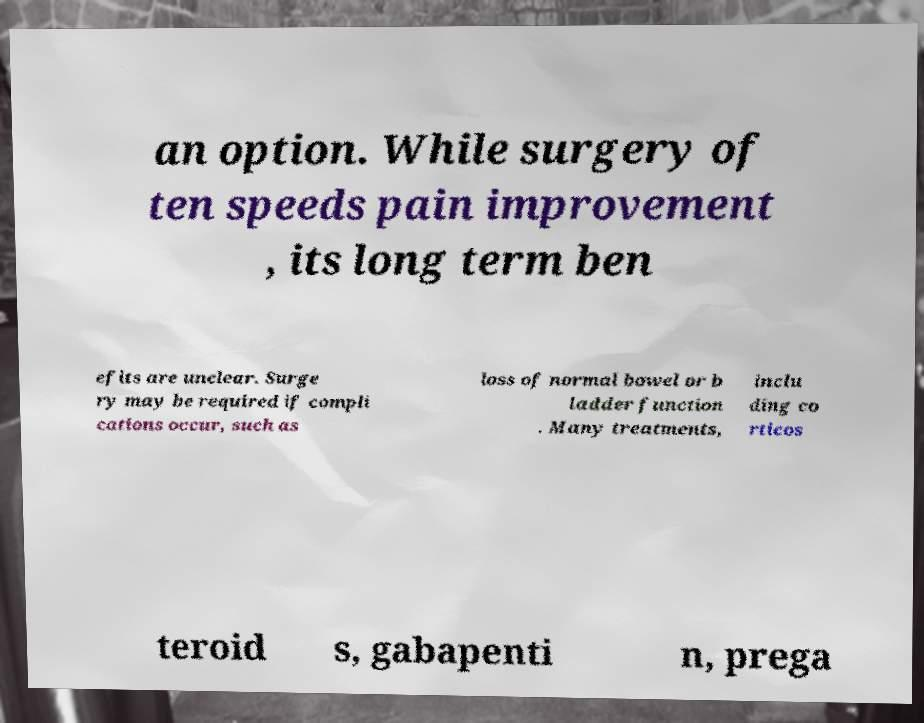I need the written content from this picture converted into text. Can you do that? an option. While surgery of ten speeds pain improvement , its long term ben efits are unclear. Surge ry may be required if compli cations occur, such as loss of normal bowel or b ladder function . Many treatments, inclu ding co rticos teroid s, gabapenti n, prega 